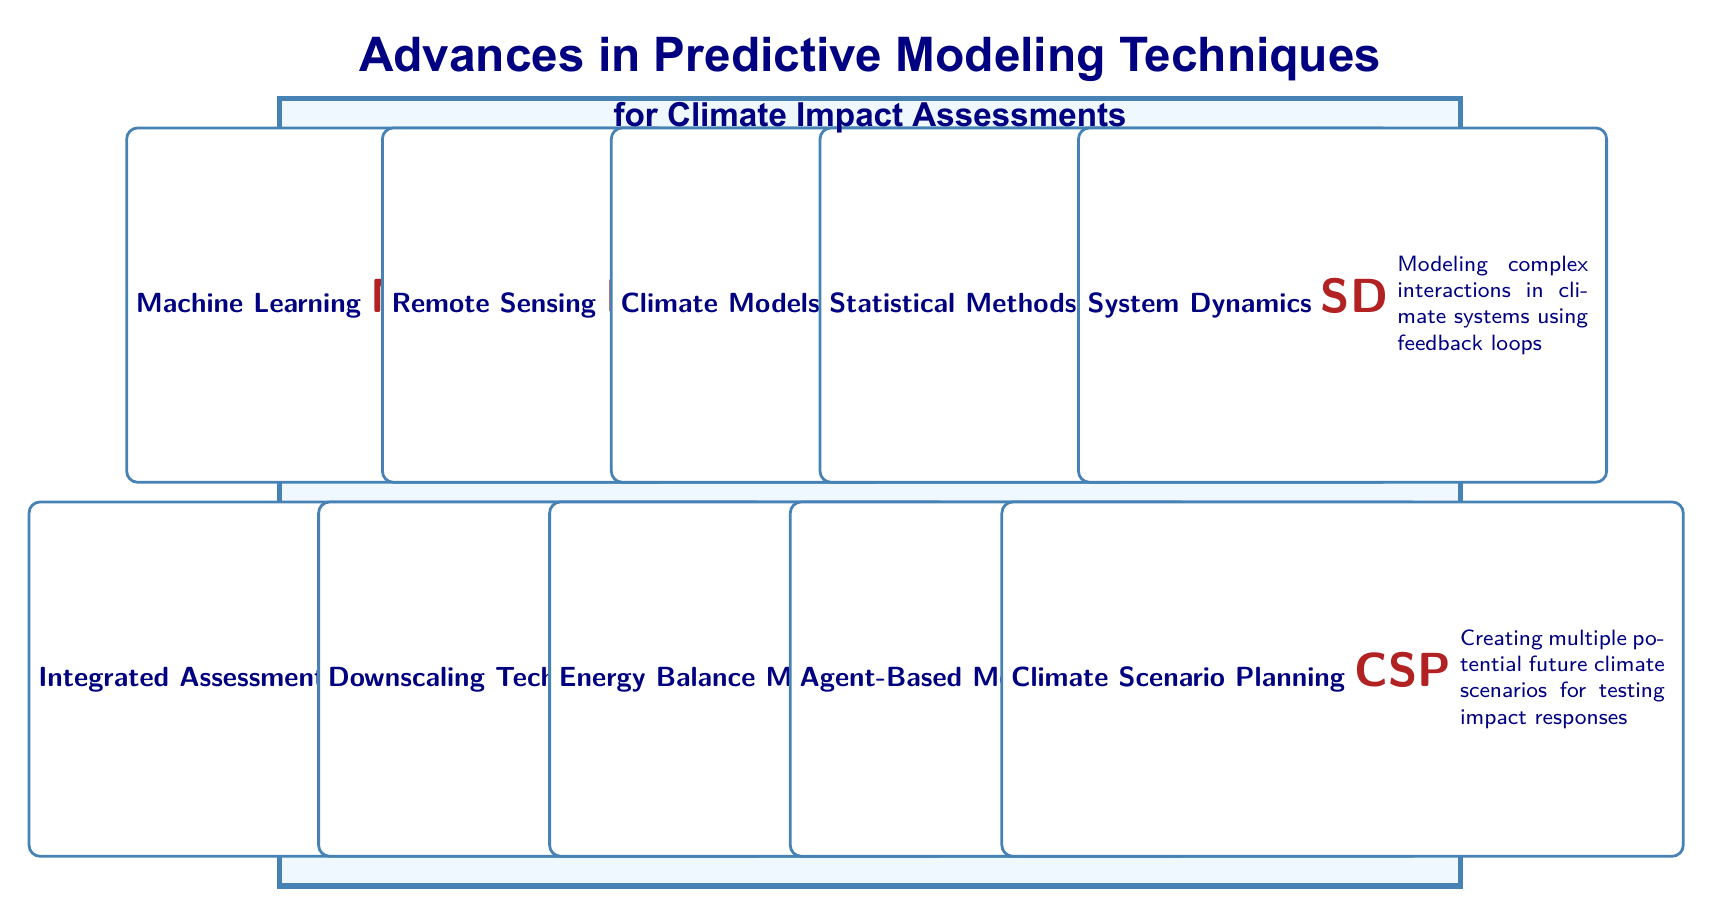What are the applications of Machine Learning? The table lists the applications of Machine Learning as follows: Temperature forecasting, Precipitation prediction, and Carbon sequestration modeling. These are directly mentioned under the applications for the Machine Learning row.
Answer: Temperature forecasting, Precipitation prediction, Carbon sequestration modeling Which modeling technique uses satellite imagery to gather climate data? According to the table, the technique that uses satellite or aerial imagery to gather data about climate phenomena is Remote Sensing, as specified in its description.
Answer: Remote Sensing Do Climate Models study ocean temperature monitoring? The description of Climate Models in the table indicates that they simulate the Earth’s climate system. The applications section does not explicitly mention ocean temperature monitoring; rather, that application belongs to Remote Sensing. Therefore, the statement is false.
Answer: No What advances have been made in Statistical Methods? The advances for Statistical Methods listed in the table are Bayesian methods, Time series analysis, and Multivariate statistics. This can be directly referenced from the advances section of the Statistical Methods row.
Answer: Bayesian methods, Time series analysis, Multivariate statistics How many applications are listed for Integrated Assessment Models? The table outlines three applications for Integrated Assessment Models: Policy impact assessment, Economic valuation of ecosystem services, and Energy and land use scenarios. This can be directly derived from the applications section for the respective row.
Answer: Three applications List the applications of Energy Balance Models and System Dynamics. For Energy Balance Models, the applications listed are Global energy budget analysis, Heat exchange assessments, and Climate sensitivity studies. For System Dynamics, the applications are Carbon cycle modeling, Energy system planning, and Ecosystem interactions. This information comes directly from the respective application sections of each row.
Answer: Energy Balance Models: Global energy budget analysis, Heat exchange assessments, Climate sensitivity studies; System Dynamics: Carbon cycle modeling, Energy system planning, Ecosystem interactions Is Downscaling Techniques focused on urban planning? The applications for Downscaling Techniques listed in the table include Local climate projection, Flood risk assessment, and Urban planning. Since urban planning is explicitly mentioned as one of its applications, the statement is true.
Answer: Yes What is the difference in the number of advances between Machine Learning and Climate Models? Machine Learning has three advances listed: Deep learning techniques, Ensemble methods, and Transfer learning. Climate Models also have three advances: Coupled ocean-atmosphere models, Regional downscaling techniques, and Improved parameterization. Since both have the same number of advances, the difference is zero.
Answer: Zero 